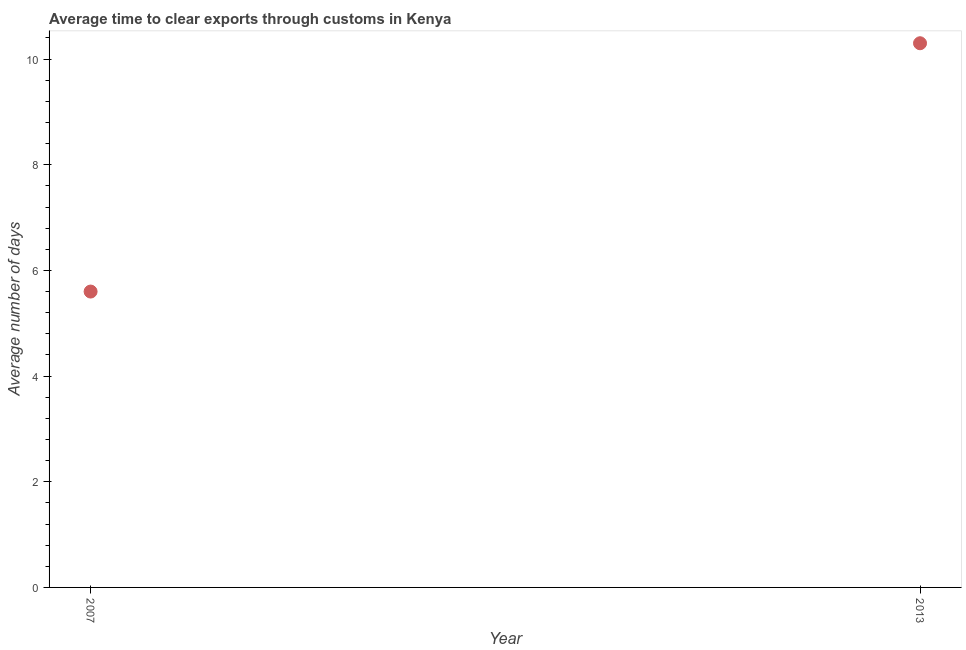Across all years, what is the minimum time to clear exports through customs?
Provide a succinct answer. 5.6. In which year was the time to clear exports through customs minimum?
Give a very brief answer. 2007. What is the sum of the time to clear exports through customs?
Make the answer very short. 15.9. What is the difference between the time to clear exports through customs in 2007 and 2013?
Give a very brief answer. -4.7. What is the average time to clear exports through customs per year?
Offer a very short reply. 7.95. What is the median time to clear exports through customs?
Ensure brevity in your answer.  7.95. What is the ratio of the time to clear exports through customs in 2007 to that in 2013?
Ensure brevity in your answer.  0.54. In how many years, is the time to clear exports through customs greater than the average time to clear exports through customs taken over all years?
Provide a succinct answer. 1. What is the difference between two consecutive major ticks on the Y-axis?
Offer a very short reply. 2. What is the title of the graph?
Ensure brevity in your answer.  Average time to clear exports through customs in Kenya. What is the label or title of the X-axis?
Your response must be concise. Year. What is the label or title of the Y-axis?
Keep it short and to the point. Average number of days. What is the difference between the Average number of days in 2007 and 2013?
Ensure brevity in your answer.  -4.7. What is the ratio of the Average number of days in 2007 to that in 2013?
Your answer should be very brief. 0.54. 